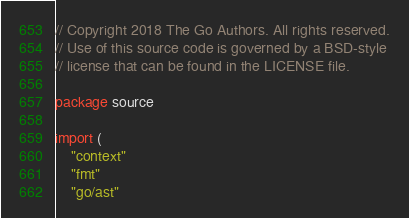<code> <loc_0><loc_0><loc_500><loc_500><_Go_>// Copyright 2018 The Go Authors. All rights reserved.
// Use of this source code is governed by a BSD-style
// license that can be found in the LICENSE file.

package source

import (
	"context"
	"fmt"
	"go/ast"</code> 